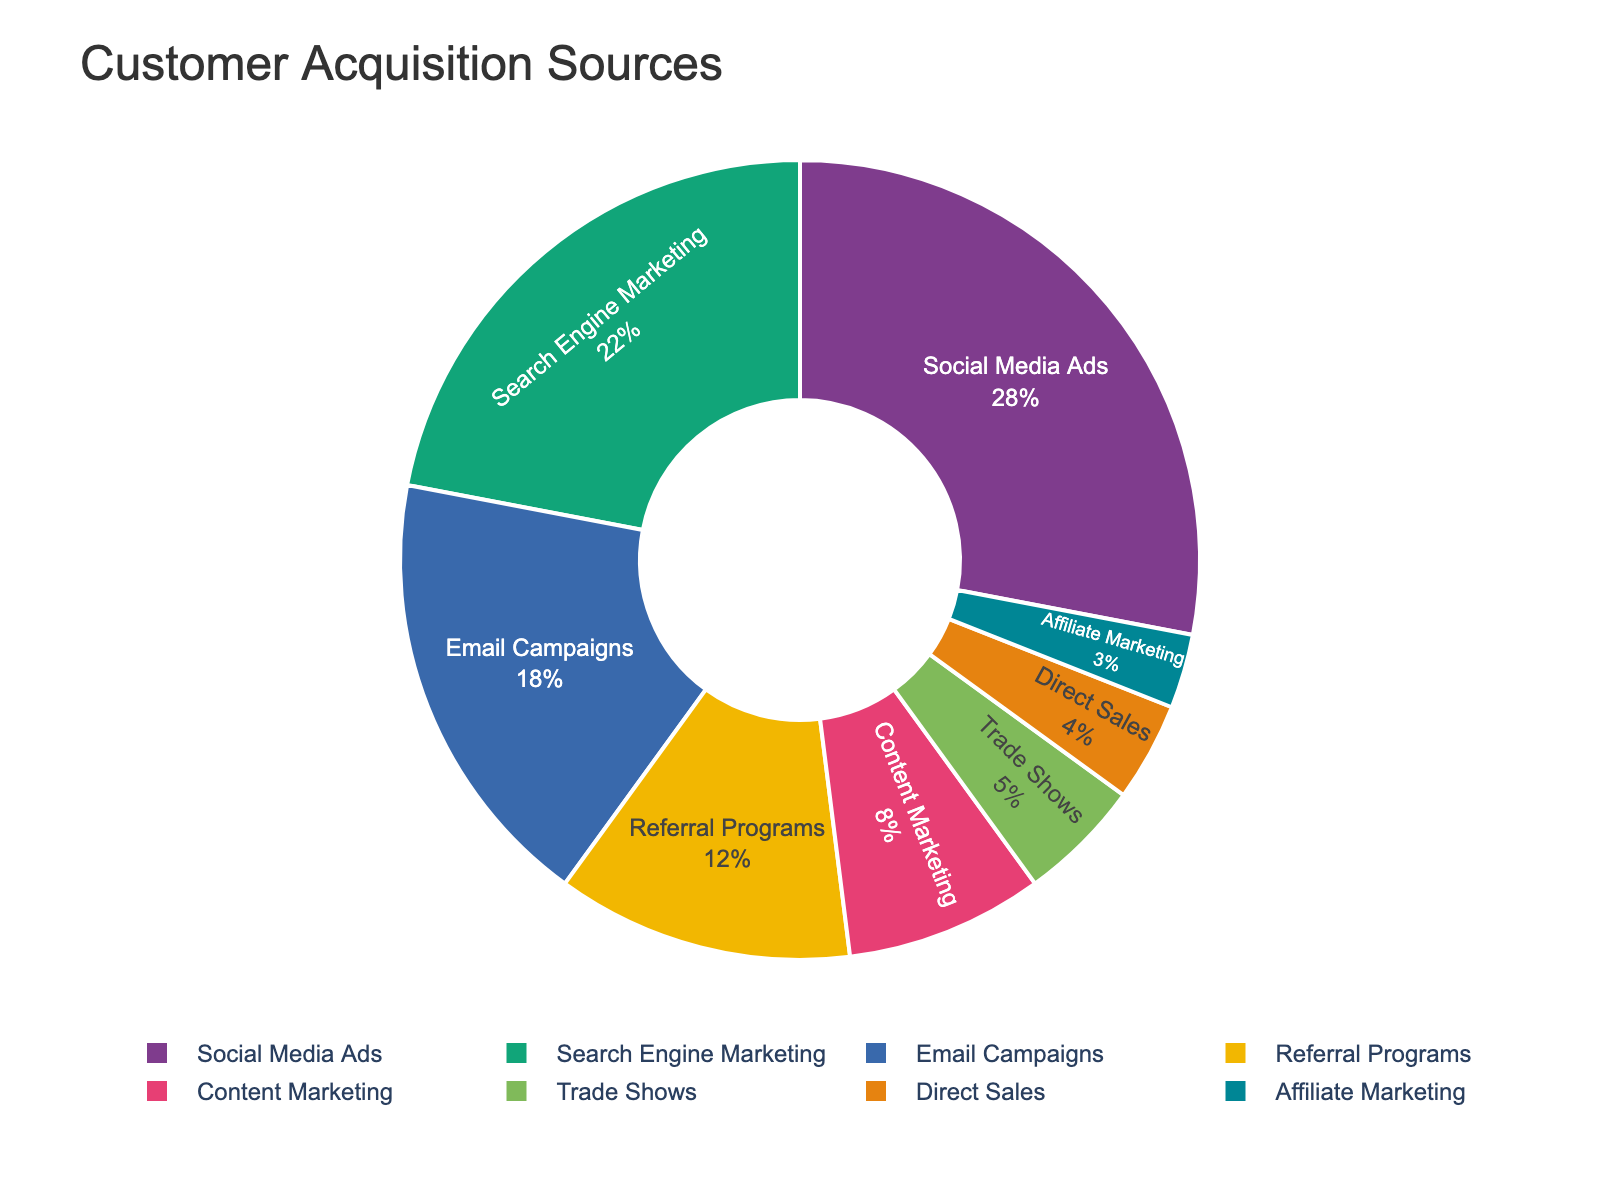Which source contributes the highest percentage of customer acquisitions? The pie chart shows that Social Media Ads have the largest slice, representing the highest percentage.
Answer: Social Media Ads What is the combined percentage of customer acquisitions through Email Campaigns and Referral Programs? Email Campaigns account for 18%, and Referral Programs account for 12%. Adding these gives 18% + 12% = 30%.
Answer: 30% How does the percentage of customer acquisitions from Trade Shows compare to Direct Sales? The pie chart shows Trade Shows at 5% and Direct Sales at 4%. Thus, Trade Shows have a higher percentage than Direct Sales.
Answer: Trade Shows is greater than Direct Sales Which sources together make up more than half of the customer acquisitions? Summing up the highest percentages until exceeding 50%: Social Media Ads (28%) + Search Engine Marketing (22%) = 50%. Since exactly 50% is included in the "more than half," the next least percentage should be considered, making it 50% + at least another smallest percentage.
Answer: Social Media Ads and Search Engine Marketing What is the difference in the percentage of customer acquisitions between Content Marketing and Affiliate Marketing? Content Marketing accounts for 8%, and Affiliate Marketing for 3%. The difference is 8% - 3% = 5%.
Answer: 5% If you sum the percentages of Trade Shows, Direct Sales, and Affiliate Marketing, what total percentage do you get? Trade Shows make up 5%, Direct Sales 4%, and Affiliate Marketing 3%. Adding them gives 5% + 4% + 3% = 12%.
Answer: 12% Which source has the smallest contribution to customer acquisitions, and what is its percentage? The pie chart shows that Affiliate Marketing has the smallest slice, representing the lowest percentage at 3%.
Answer: Affiliate Marketing at 3% What percentage do Search Engine Marketing and Social Media Ads contribute together? Search Engine Marketing accounts for 22%, and Social Media Ads for 28%. Adding these gives 22% + 28% = 50%.
Answer: 50% Is the total percentage of Email Campaigns and Content Marketing greater or less than that of Social Media Ads? Email Campaigns make up 18%, and Content Marketing 8%. Their total is 18% + 8% = 26%. Social Media Ads contribute 28%, which is higher than 26%.
Answer: Less than How does the percentage contribution of Referral Programs compare to that of Trade Shows and Direct Sales combined? Referral Programs account for 12%. Trade Shows (5%) and Direct Sales (4%) together make up 5% + 4% = 9%, which is less than 12%.
Answer: Referral Programs are greater than Trade Shows and Direct Sales combined 